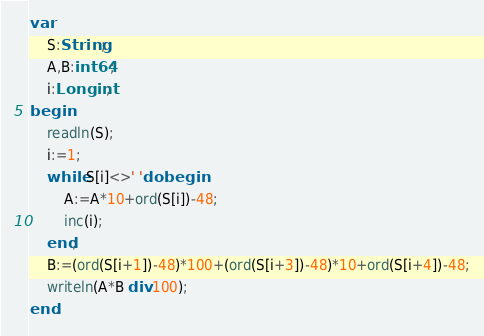Convert code to text. <code><loc_0><loc_0><loc_500><loc_500><_Pascal_>var
	S:String;
	A,B:int64;
	i:Longint;
begin
	readln(S);
	i:=1;
	while S[i]<>' 'do begin
		A:=A*10+ord(S[i])-48;
		inc(i);
	end;
	B:=(ord(S[i+1])-48)*100+(ord(S[i+3])-48)*10+ord(S[i+4])-48;
	writeln(A*B div 100);
end.
</code> 